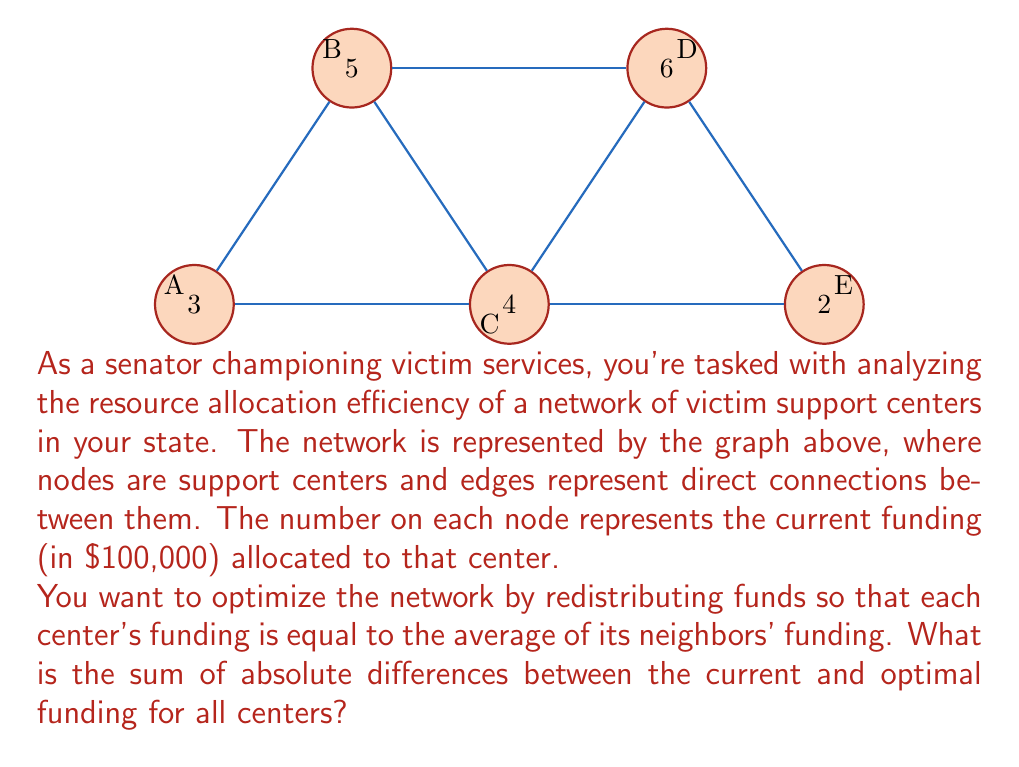Help me with this question. Let's approach this step-by-step:

1) First, we need to calculate the optimal funding for each center based on the average of its neighbors' current funding.

   For A: $(5 + 4) / 2 = 4.5$
   For B: $(3 + 4 + 6) / 3 = 4.33$
   For C: $(3 + 5 + 6 + 2) / 4 = 4$
   For D: $(5 + 4 + 2) / 3 = 3.67$
   For E: $(4 + 6) / 2 = 5$

2) Now, we calculate the absolute difference between the current and optimal funding for each center:

   A: $|3 - 4.5| = 1.5$
   B: $|5 - 4.33| = 0.67$
   C: $|4 - 4| = 0$
   D: $|6 - 3.67| = 2.33$
   E: $|2 - 5| = 3$

3) Finally, we sum these differences:

   $$1.5 + 0.67 + 0 + 2.33 + 3 = 7.5$$

Therefore, the sum of absolute differences between the current and optimal funding for all centers is 7.5 (in $100,000).
Answer: $750,000 